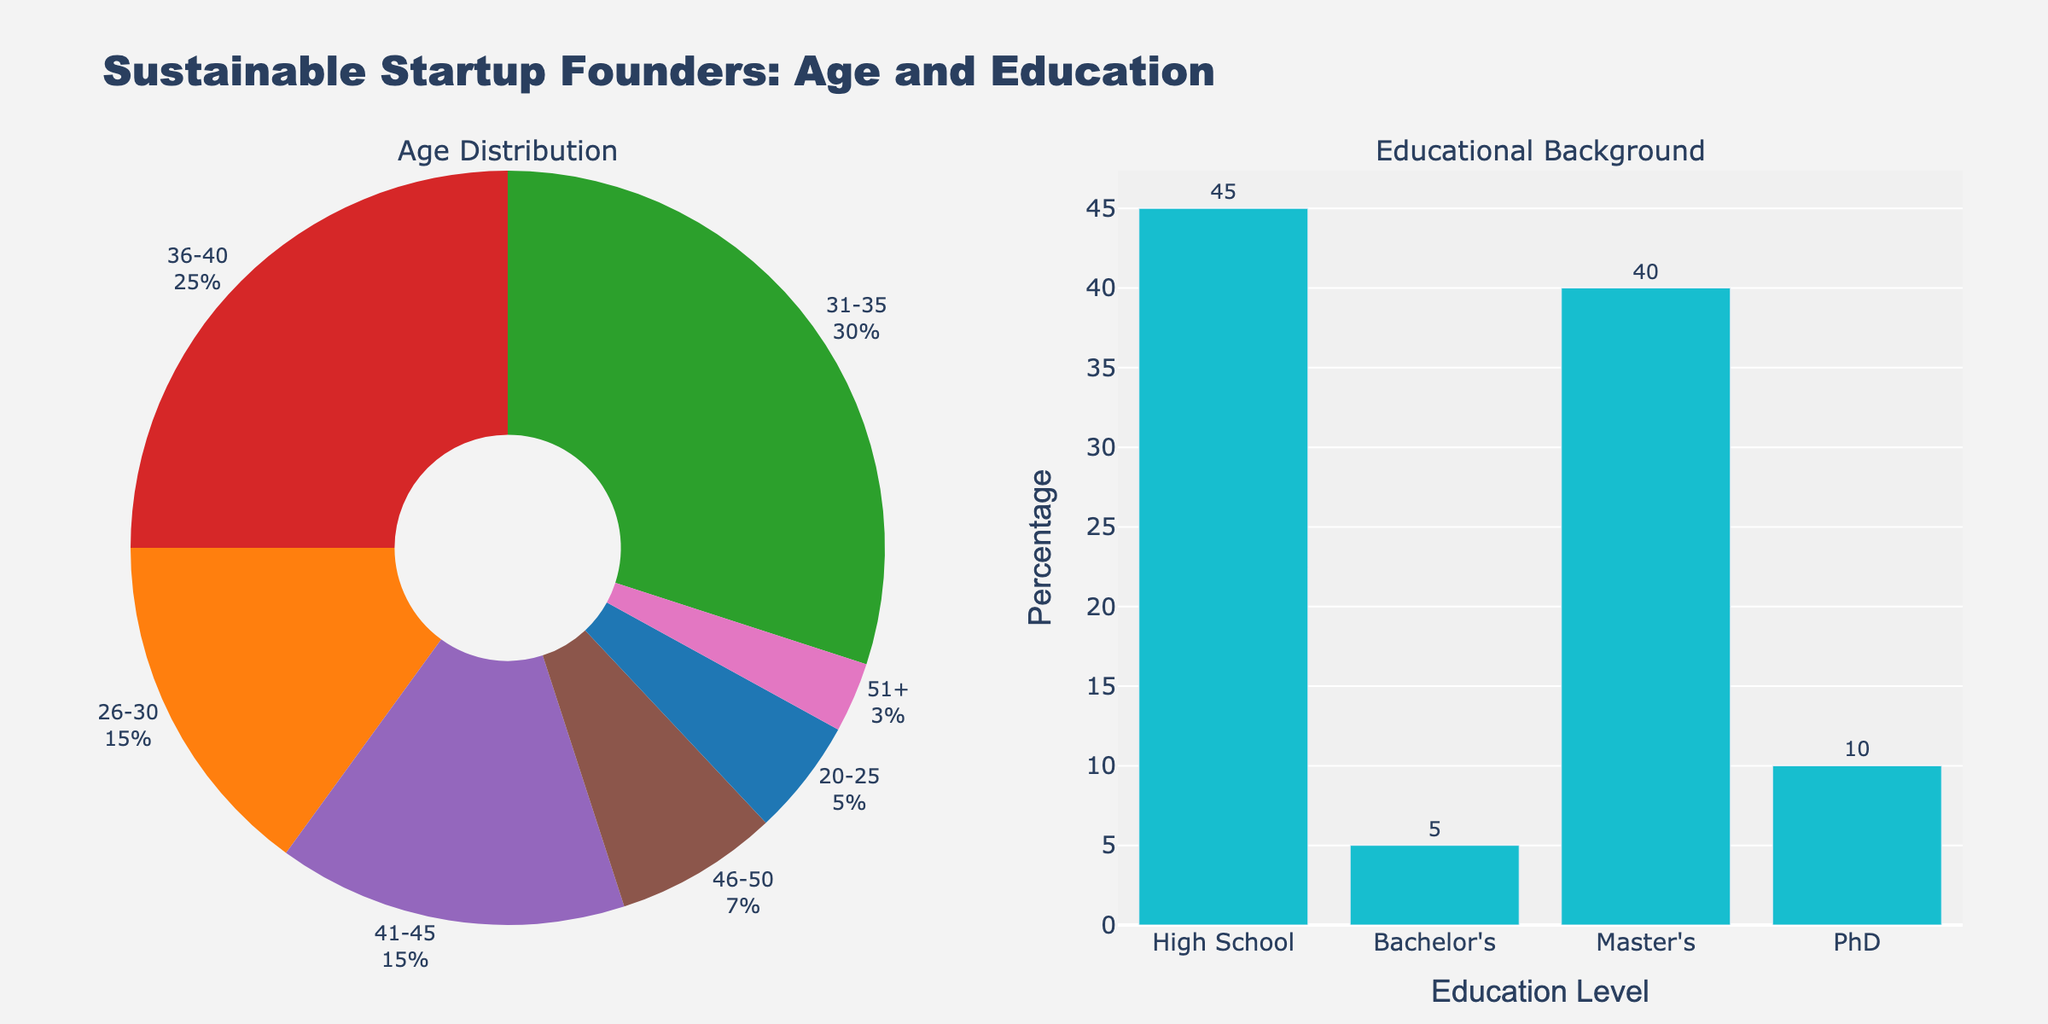What is the title of the figure? The title of the figure is located at the top and clearly states the main focus of the plots shown.
Answer: "Sustainable Startup Founders: Age and Education" How many age groups are represented in the pie chart? By looking at the pie chart, you can count the slices representing different age groups.
Answer: 7 Which age group has the highest percentage of founders? Observing the pie chart, the largest slice represents the age group with the highest percentage.
Answer: 31-35 What is the total percentage of founders with a Master's degree? Refer to the bar chart and sum the values associated with the Master's degree category. There are two bars representing Master's degrees, 25% + 15% = 40%.
Answer: 40% Compare the percentage of founders aged 41-45 and those aged 46-50. Look at the slices in the pie chart corresponding to these age groups. The 41-45 age group has a larger slice than the 46-50 age group.
Answer: 15% vs. 7% Which educational background has the least representation among founders? The height of the bars in the bar chart indicates the percentages; the shortest bar corresponds to the least representation.
Answer: PhD What is the combined percentage of founders aged 31-40? Add the percentages from the age groups 31-35 and 36-40 from the pie chart. 30% (31-35) + 25% (36-40) = 55%.
Answer: 55% How does the ratio of founders with a Bachelor's degree compare to those with a PhD? Add the percentages of founders with a Bachelor's degree and compare it to the sum of founders with a PhD, then express it as a ratio. Bachelor's (15% + 30%) vs. PhD (7% + 3%). 45:10 or simplified 4.5:1.
Answer: 4.5:1 What age group are founders with a PhD most likely to fall into? Look at the age groups listed with PhD qualifications in the pie chart. Identify the age group with the highest percentage among them.
Answer: 46-50 Which chart shows the educational background of the startup founders? By examining the figure, note that the bar chart on the right indicates the educational backgrounds.
Answer: Bar chart 